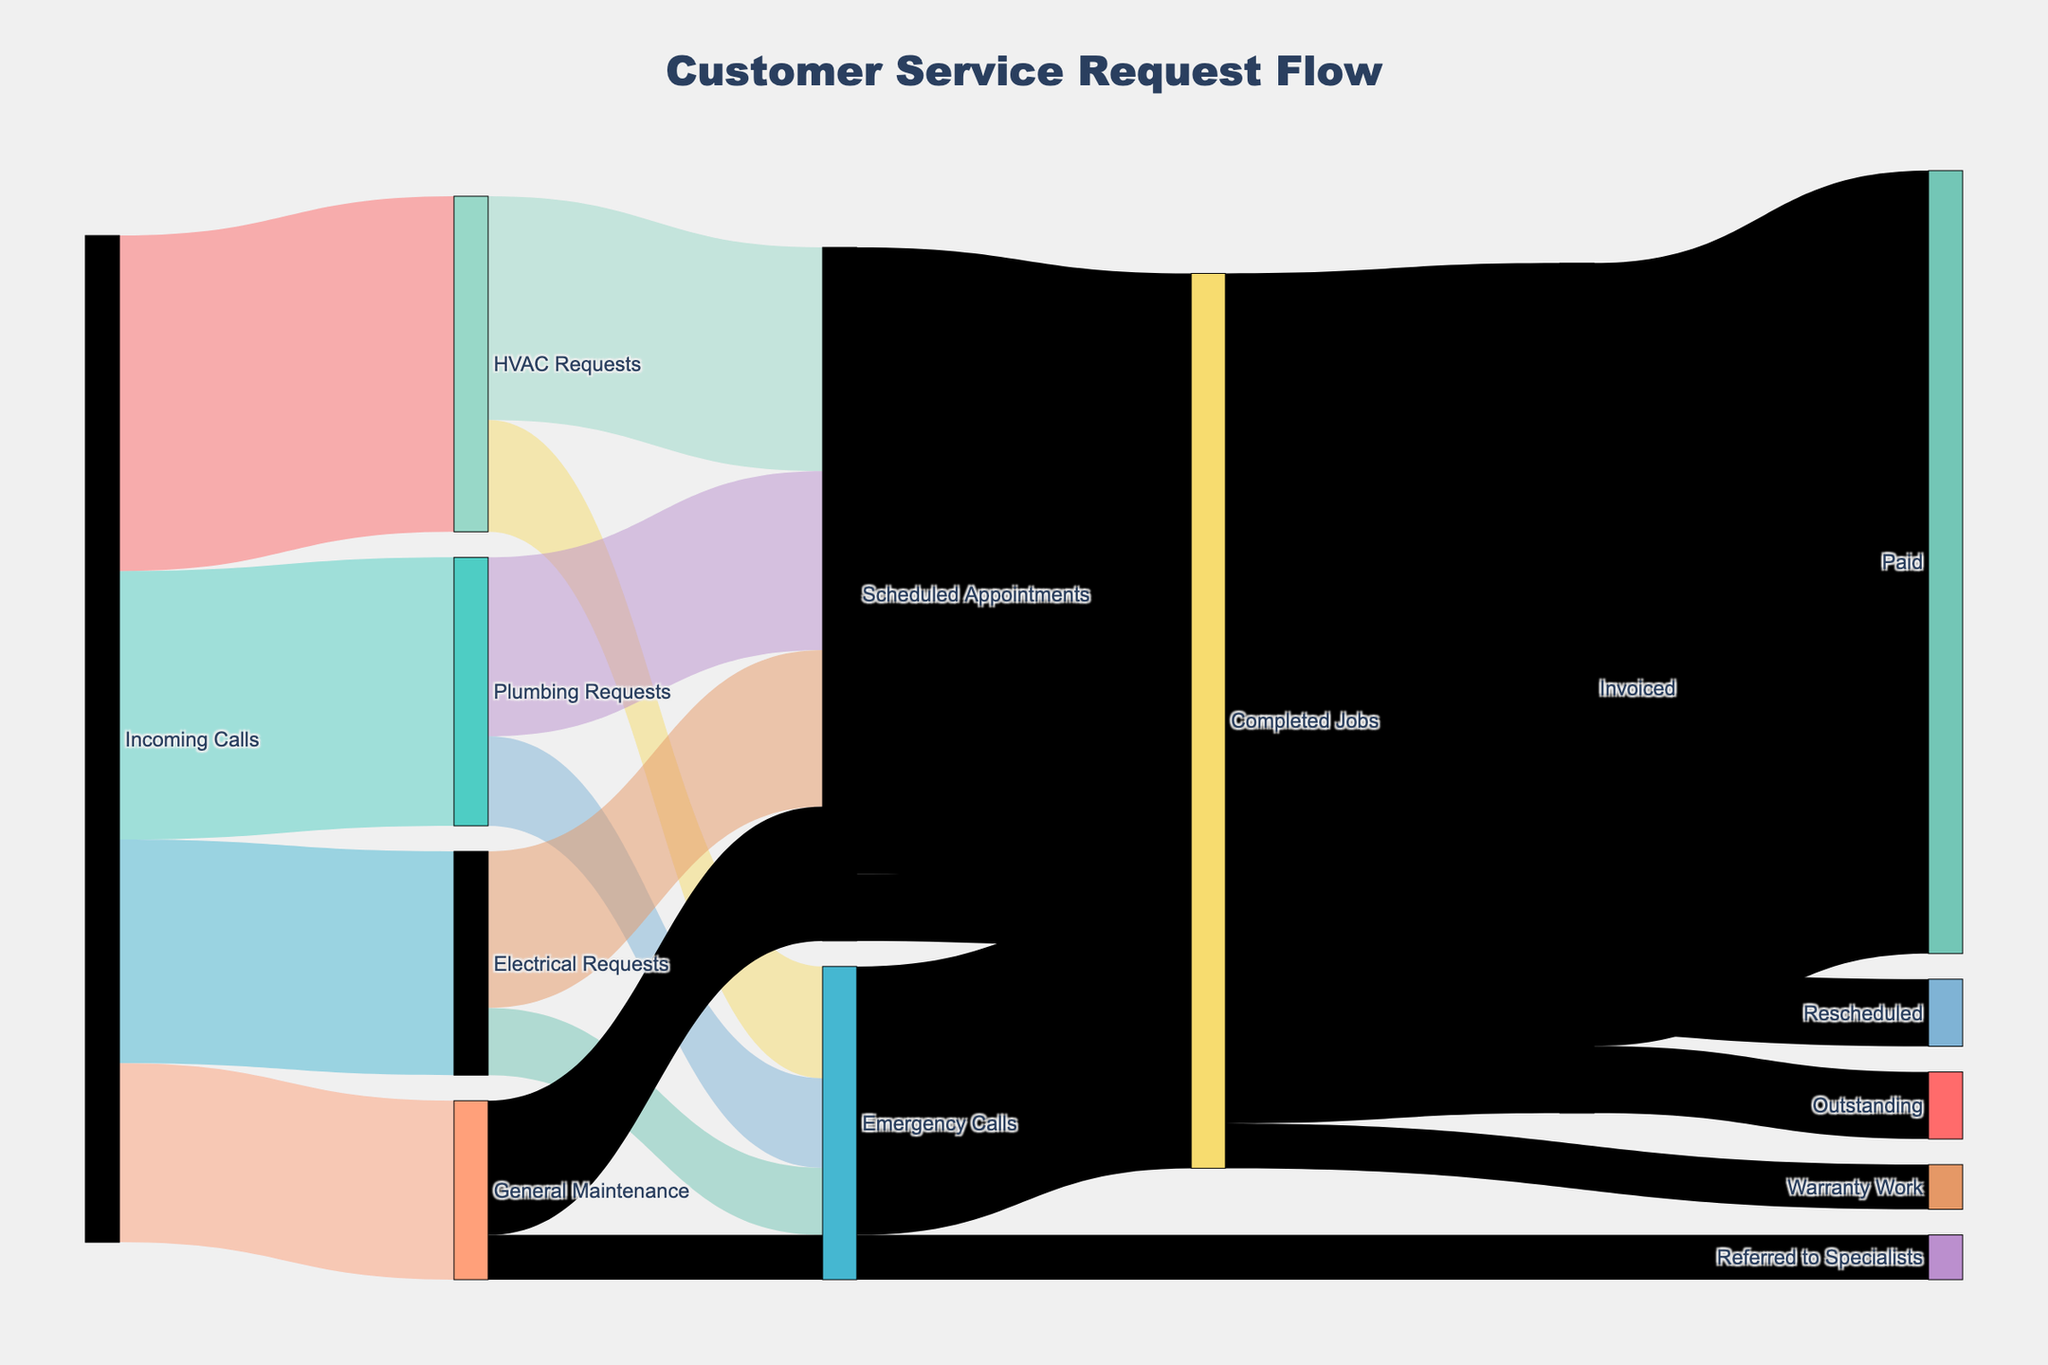What is the most common type of service request from incoming calls? The diagram shows four types of service requests coming from incoming calls: HVAC Requests, Plumbing Requests, Electrical Requests, and General Maintenance. The values for each are 150, 120, 100, and 80 respectively. Since 150 is the highest value, HVAC Requests is the most common.
Answer: HVAC Requests How many service requests come in for Plumbing? The diagram shows the value of service requests originating from incoming calls for Plumbing Requests, which is 120.
Answer: 120 What is the total number of completed jobs? To determine the total number of completed jobs, sum the Scheduled Appointments to Completed Jobs flow (280) and Emergency Calls to Completed Jobs flow (120). So, the total is 280 + 120 = 400.
Answer: 400 How many Scheduled Appointments resulted in rescheduling? According to the diagram, the number of Scheduled Appointments that were rescheduled is 30.
Answer: 30 Which service request type has more emergency calls: HVAC or Plumbing? The diagram shows the value of emergency calls for HVAC Requests (50) and Plumbing Requests (40). Since 50 is greater than 40, HVAC Requests has more emergency calls.
Answer: HVAC Requests What is the total number of requests for Scheduled Appointments? Sum the number of Scheduled Appointments from all service types: HVAC (100), Plumbing (80), Electrical (70), General Maintenance (60). The total is 100 + 80 + 70 + 60 = 310.
Answer: 310 How many invoiced jobs have been paid? The diagram shows that 350 invoiced jobs have been paid.
Answer: 350 How many service requests were referred to specialists from Emergency Calls? The diagram shows that 20 Emergency Calls were referred to specialists.
Answer: 20 Which has a higher value: completed jobs from Scheduled Appointments or completed jobs from Emergency Calls? The diagram shows the value for completed jobs from Scheduled Appointments (280) and from Emergency Calls (120). Since 280 is higher than 120, completed jobs from Scheduled Appointments has a higher value.
Answer: Completed jobs from Scheduled Appointments What proportion of invoiced jobs remain outstanding? The diagram shows 30 out of 380 invoiced jobs are outstanding. The proportion is 30/380 = 0.0789 or roughly 7.9%.
Answer: 7.9% 